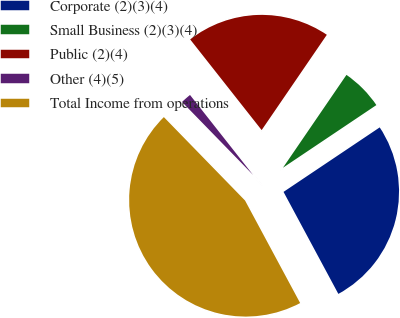Convert chart to OTSL. <chart><loc_0><loc_0><loc_500><loc_500><pie_chart><fcel>Corporate (2)(3)(4)<fcel>Small Business (2)(3)(4)<fcel>Public (2)(4)<fcel>Other (4)(5)<fcel>Total Income from operations<nl><fcel>26.55%<fcel>6.05%<fcel>20.17%<fcel>1.66%<fcel>45.56%<nl></chart> 